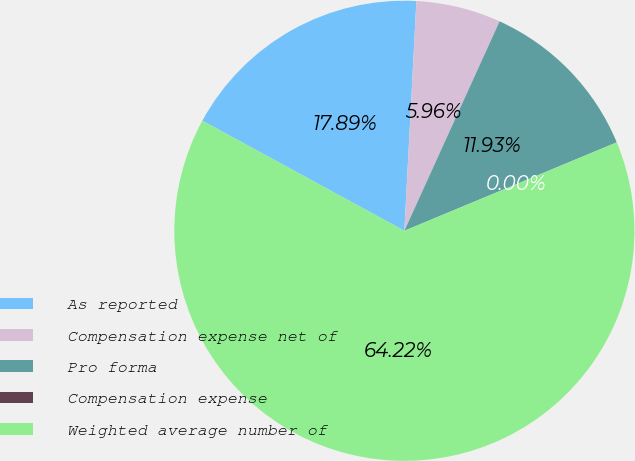<chart> <loc_0><loc_0><loc_500><loc_500><pie_chart><fcel>As reported<fcel>Compensation expense net of<fcel>Pro forma<fcel>Compensation expense<fcel>Weighted average number of<nl><fcel>17.89%<fcel>5.96%<fcel>11.93%<fcel>0.0%<fcel>64.22%<nl></chart> 